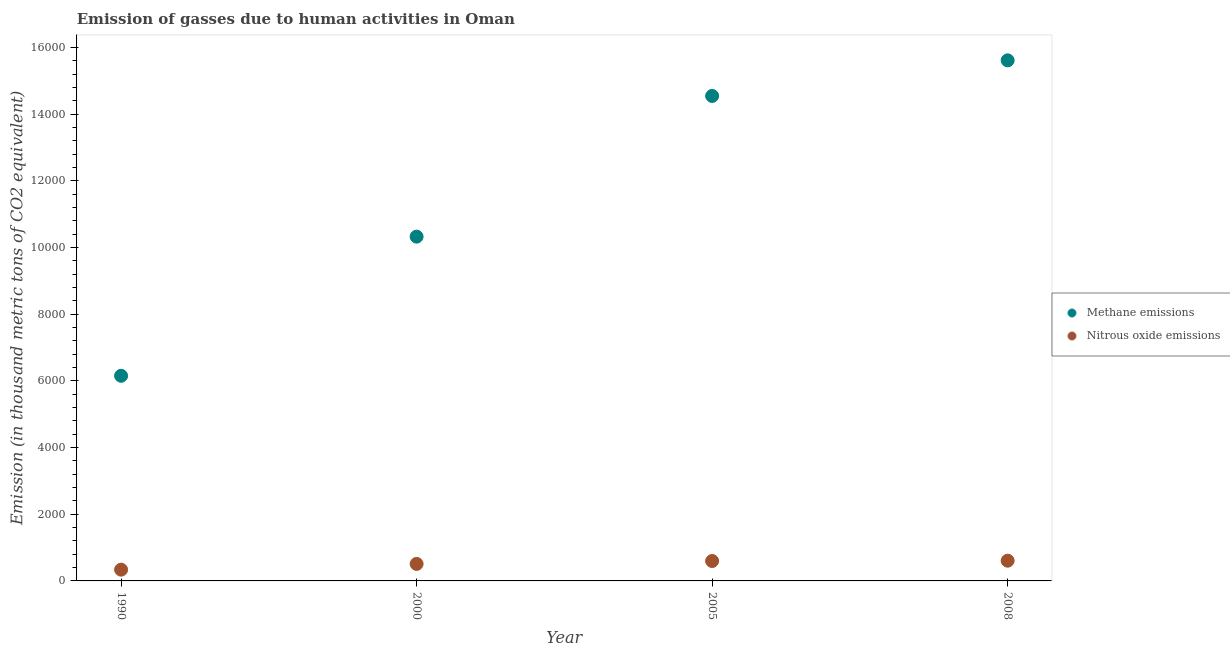How many different coloured dotlines are there?
Keep it short and to the point. 2. What is the amount of nitrous oxide emissions in 1990?
Ensure brevity in your answer.  338.2. Across all years, what is the maximum amount of methane emissions?
Offer a terse response. 1.56e+04. Across all years, what is the minimum amount of nitrous oxide emissions?
Give a very brief answer. 338.2. In which year was the amount of nitrous oxide emissions maximum?
Give a very brief answer. 2008. What is the total amount of methane emissions in the graph?
Make the answer very short. 4.66e+04. What is the difference between the amount of methane emissions in 1990 and that in 2008?
Give a very brief answer. -9461.4. What is the difference between the amount of methane emissions in 1990 and the amount of nitrous oxide emissions in 2008?
Make the answer very short. 5546.1. What is the average amount of nitrous oxide emissions per year?
Your response must be concise. 513.22. In the year 1990, what is the difference between the amount of nitrous oxide emissions and amount of methane emissions?
Keep it short and to the point. -5814.7. In how many years, is the amount of methane emissions greater than 15200 thousand metric tons?
Offer a very short reply. 1. What is the ratio of the amount of nitrous oxide emissions in 1990 to that in 2005?
Provide a succinct answer. 0.57. Is the amount of nitrous oxide emissions in 1990 less than that in 2000?
Your answer should be compact. Yes. What is the difference between the highest and the second highest amount of methane emissions?
Make the answer very short. 1068.2. What is the difference between the highest and the lowest amount of methane emissions?
Your answer should be very brief. 9461.4. In how many years, is the amount of methane emissions greater than the average amount of methane emissions taken over all years?
Offer a terse response. 2. Is the amount of methane emissions strictly greater than the amount of nitrous oxide emissions over the years?
Offer a terse response. Yes. Is the amount of nitrous oxide emissions strictly less than the amount of methane emissions over the years?
Your answer should be very brief. Yes. How many dotlines are there?
Provide a short and direct response. 2. How many years are there in the graph?
Your answer should be very brief. 4. What is the difference between two consecutive major ticks on the Y-axis?
Ensure brevity in your answer.  2000. Are the values on the major ticks of Y-axis written in scientific E-notation?
Give a very brief answer. No. Does the graph contain any zero values?
Keep it short and to the point. No. How many legend labels are there?
Offer a terse response. 2. How are the legend labels stacked?
Offer a very short reply. Vertical. What is the title of the graph?
Your answer should be very brief. Emission of gasses due to human activities in Oman. What is the label or title of the X-axis?
Your response must be concise. Year. What is the label or title of the Y-axis?
Your answer should be compact. Emission (in thousand metric tons of CO2 equivalent). What is the Emission (in thousand metric tons of CO2 equivalent) in Methane emissions in 1990?
Offer a very short reply. 6152.9. What is the Emission (in thousand metric tons of CO2 equivalent) of Nitrous oxide emissions in 1990?
Provide a succinct answer. 338.2. What is the Emission (in thousand metric tons of CO2 equivalent) in Methane emissions in 2000?
Your response must be concise. 1.03e+04. What is the Emission (in thousand metric tons of CO2 equivalent) in Nitrous oxide emissions in 2000?
Provide a succinct answer. 510.6. What is the Emission (in thousand metric tons of CO2 equivalent) of Methane emissions in 2005?
Give a very brief answer. 1.45e+04. What is the Emission (in thousand metric tons of CO2 equivalent) in Nitrous oxide emissions in 2005?
Ensure brevity in your answer.  597.3. What is the Emission (in thousand metric tons of CO2 equivalent) of Methane emissions in 2008?
Offer a terse response. 1.56e+04. What is the Emission (in thousand metric tons of CO2 equivalent) of Nitrous oxide emissions in 2008?
Your answer should be very brief. 606.8. Across all years, what is the maximum Emission (in thousand metric tons of CO2 equivalent) in Methane emissions?
Provide a succinct answer. 1.56e+04. Across all years, what is the maximum Emission (in thousand metric tons of CO2 equivalent) in Nitrous oxide emissions?
Offer a terse response. 606.8. Across all years, what is the minimum Emission (in thousand metric tons of CO2 equivalent) of Methane emissions?
Ensure brevity in your answer.  6152.9. Across all years, what is the minimum Emission (in thousand metric tons of CO2 equivalent) in Nitrous oxide emissions?
Your response must be concise. 338.2. What is the total Emission (in thousand metric tons of CO2 equivalent) of Methane emissions in the graph?
Your answer should be very brief. 4.66e+04. What is the total Emission (in thousand metric tons of CO2 equivalent) of Nitrous oxide emissions in the graph?
Offer a very short reply. 2052.9. What is the difference between the Emission (in thousand metric tons of CO2 equivalent) of Methane emissions in 1990 and that in 2000?
Make the answer very short. -4173.4. What is the difference between the Emission (in thousand metric tons of CO2 equivalent) in Nitrous oxide emissions in 1990 and that in 2000?
Give a very brief answer. -172.4. What is the difference between the Emission (in thousand metric tons of CO2 equivalent) in Methane emissions in 1990 and that in 2005?
Your answer should be compact. -8393.2. What is the difference between the Emission (in thousand metric tons of CO2 equivalent) of Nitrous oxide emissions in 1990 and that in 2005?
Offer a very short reply. -259.1. What is the difference between the Emission (in thousand metric tons of CO2 equivalent) in Methane emissions in 1990 and that in 2008?
Make the answer very short. -9461.4. What is the difference between the Emission (in thousand metric tons of CO2 equivalent) in Nitrous oxide emissions in 1990 and that in 2008?
Provide a succinct answer. -268.6. What is the difference between the Emission (in thousand metric tons of CO2 equivalent) in Methane emissions in 2000 and that in 2005?
Keep it short and to the point. -4219.8. What is the difference between the Emission (in thousand metric tons of CO2 equivalent) in Nitrous oxide emissions in 2000 and that in 2005?
Your response must be concise. -86.7. What is the difference between the Emission (in thousand metric tons of CO2 equivalent) of Methane emissions in 2000 and that in 2008?
Offer a very short reply. -5288. What is the difference between the Emission (in thousand metric tons of CO2 equivalent) of Nitrous oxide emissions in 2000 and that in 2008?
Make the answer very short. -96.2. What is the difference between the Emission (in thousand metric tons of CO2 equivalent) in Methane emissions in 2005 and that in 2008?
Provide a succinct answer. -1068.2. What is the difference between the Emission (in thousand metric tons of CO2 equivalent) of Nitrous oxide emissions in 2005 and that in 2008?
Give a very brief answer. -9.5. What is the difference between the Emission (in thousand metric tons of CO2 equivalent) of Methane emissions in 1990 and the Emission (in thousand metric tons of CO2 equivalent) of Nitrous oxide emissions in 2000?
Your answer should be compact. 5642.3. What is the difference between the Emission (in thousand metric tons of CO2 equivalent) in Methane emissions in 1990 and the Emission (in thousand metric tons of CO2 equivalent) in Nitrous oxide emissions in 2005?
Provide a succinct answer. 5555.6. What is the difference between the Emission (in thousand metric tons of CO2 equivalent) in Methane emissions in 1990 and the Emission (in thousand metric tons of CO2 equivalent) in Nitrous oxide emissions in 2008?
Make the answer very short. 5546.1. What is the difference between the Emission (in thousand metric tons of CO2 equivalent) of Methane emissions in 2000 and the Emission (in thousand metric tons of CO2 equivalent) of Nitrous oxide emissions in 2005?
Offer a very short reply. 9729. What is the difference between the Emission (in thousand metric tons of CO2 equivalent) of Methane emissions in 2000 and the Emission (in thousand metric tons of CO2 equivalent) of Nitrous oxide emissions in 2008?
Offer a terse response. 9719.5. What is the difference between the Emission (in thousand metric tons of CO2 equivalent) of Methane emissions in 2005 and the Emission (in thousand metric tons of CO2 equivalent) of Nitrous oxide emissions in 2008?
Offer a very short reply. 1.39e+04. What is the average Emission (in thousand metric tons of CO2 equivalent) in Methane emissions per year?
Your response must be concise. 1.17e+04. What is the average Emission (in thousand metric tons of CO2 equivalent) of Nitrous oxide emissions per year?
Offer a terse response. 513.23. In the year 1990, what is the difference between the Emission (in thousand metric tons of CO2 equivalent) in Methane emissions and Emission (in thousand metric tons of CO2 equivalent) in Nitrous oxide emissions?
Offer a very short reply. 5814.7. In the year 2000, what is the difference between the Emission (in thousand metric tons of CO2 equivalent) of Methane emissions and Emission (in thousand metric tons of CO2 equivalent) of Nitrous oxide emissions?
Your answer should be very brief. 9815.7. In the year 2005, what is the difference between the Emission (in thousand metric tons of CO2 equivalent) of Methane emissions and Emission (in thousand metric tons of CO2 equivalent) of Nitrous oxide emissions?
Offer a terse response. 1.39e+04. In the year 2008, what is the difference between the Emission (in thousand metric tons of CO2 equivalent) of Methane emissions and Emission (in thousand metric tons of CO2 equivalent) of Nitrous oxide emissions?
Provide a succinct answer. 1.50e+04. What is the ratio of the Emission (in thousand metric tons of CO2 equivalent) in Methane emissions in 1990 to that in 2000?
Offer a very short reply. 0.6. What is the ratio of the Emission (in thousand metric tons of CO2 equivalent) in Nitrous oxide emissions in 1990 to that in 2000?
Provide a succinct answer. 0.66. What is the ratio of the Emission (in thousand metric tons of CO2 equivalent) of Methane emissions in 1990 to that in 2005?
Your response must be concise. 0.42. What is the ratio of the Emission (in thousand metric tons of CO2 equivalent) of Nitrous oxide emissions in 1990 to that in 2005?
Offer a terse response. 0.57. What is the ratio of the Emission (in thousand metric tons of CO2 equivalent) of Methane emissions in 1990 to that in 2008?
Give a very brief answer. 0.39. What is the ratio of the Emission (in thousand metric tons of CO2 equivalent) in Nitrous oxide emissions in 1990 to that in 2008?
Offer a terse response. 0.56. What is the ratio of the Emission (in thousand metric tons of CO2 equivalent) in Methane emissions in 2000 to that in 2005?
Keep it short and to the point. 0.71. What is the ratio of the Emission (in thousand metric tons of CO2 equivalent) of Nitrous oxide emissions in 2000 to that in 2005?
Your answer should be compact. 0.85. What is the ratio of the Emission (in thousand metric tons of CO2 equivalent) of Methane emissions in 2000 to that in 2008?
Keep it short and to the point. 0.66. What is the ratio of the Emission (in thousand metric tons of CO2 equivalent) of Nitrous oxide emissions in 2000 to that in 2008?
Your answer should be compact. 0.84. What is the ratio of the Emission (in thousand metric tons of CO2 equivalent) of Methane emissions in 2005 to that in 2008?
Offer a terse response. 0.93. What is the ratio of the Emission (in thousand metric tons of CO2 equivalent) of Nitrous oxide emissions in 2005 to that in 2008?
Provide a short and direct response. 0.98. What is the difference between the highest and the second highest Emission (in thousand metric tons of CO2 equivalent) in Methane emissions?
Your response must be concise. 1068.2. What is the difference between the highest and the lowest Emission (in thousand metric tons of CO2 equivalent) in Methane emissions?
Offer a very short reply. 9461.4. What is the difference between the highest and the lowest Emission (in thousand metric tons of CO2 equivalent) of Nitrous oxide emissions?
Your answer should be compact. 268.6. 